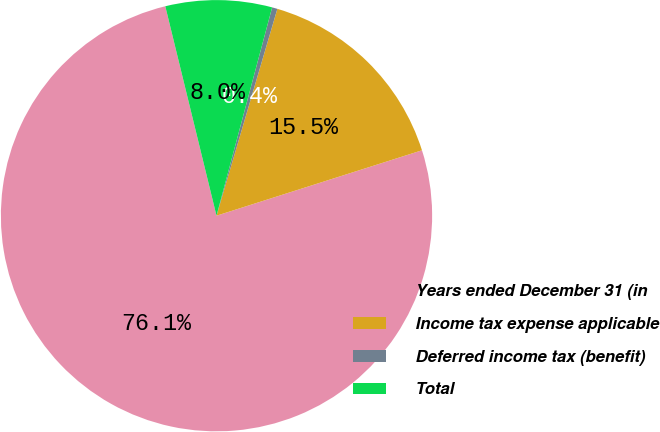Convert chart to OTSL. <chart><loc_0><loc_0><loc_500><loc_500><pie_chart><fcel>Years ended December 31 (in<fcel>Income tax expense applicable<fcel>Deferred income tax (benefit)<fcel>Total<nl><fcel>76.09%<fcel>15.54%<fcel>0.4%<fcel>7.97%<nl></chart> 